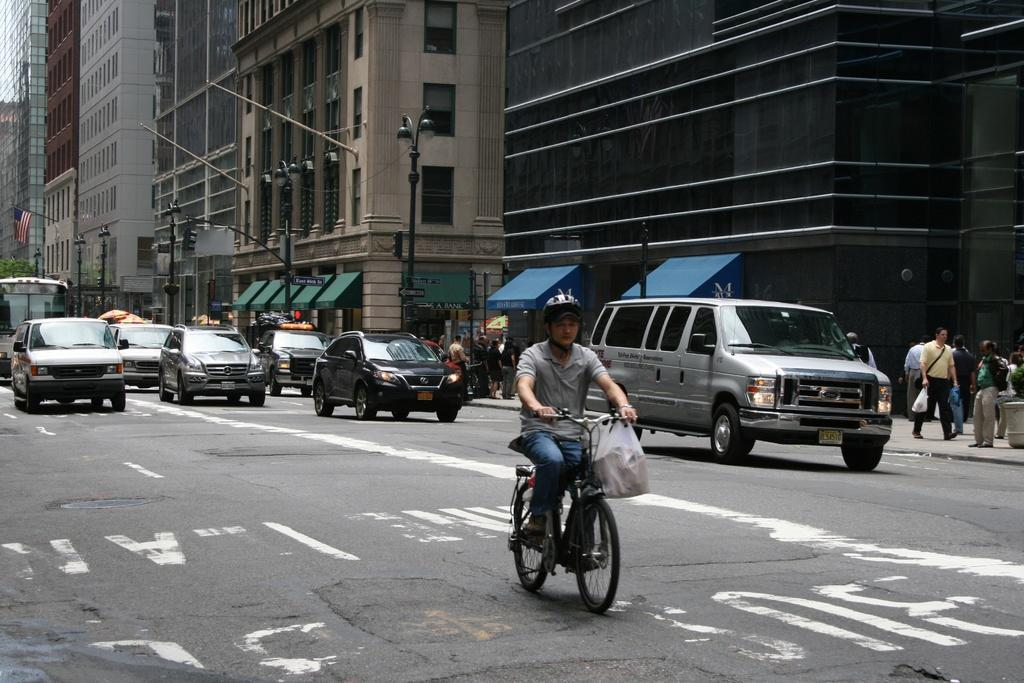What is the person in the image doing? There is a person riding a bicycle on the road. What else can be seen on the road in the image? There are cars on the road. What are the people near the road doing? There are pedestrians walking on the footpath. What is visible in the background of the image? There are buildings near the road. Can you see any eggs being transported by the goat on the hill in the image? There is no goat or hill present in the image, and therefore no such activity can be observed. 